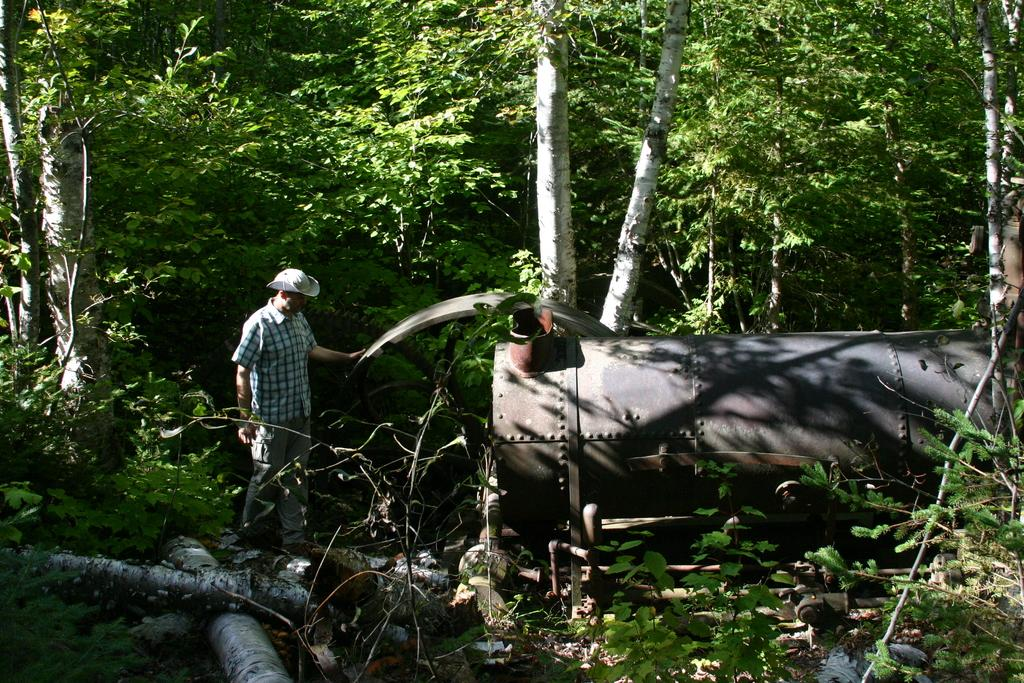Who is present in the image? There is a man in the image. What is the man wearing on his head? The man is wearing a hat. What object can be seen in the image that is made of metal? There is a metal tank in the image. What type of natural environment is visible in the background of the image? There are trees and plants in the background of the image. What type of fruit is hanging from the branches of the trees in the image? There is no fruit visible in the image; only trees and plants can be seen in the background. 